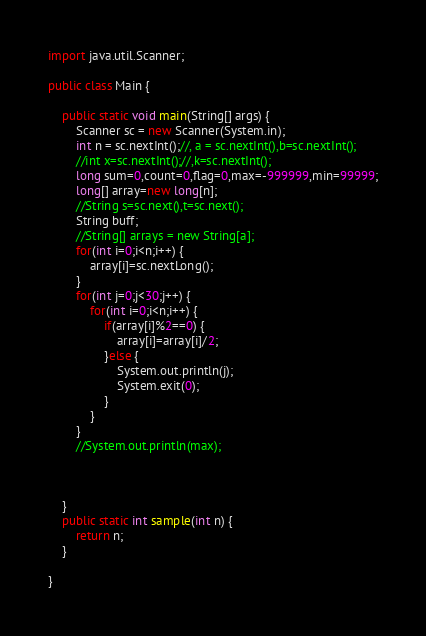Convert code to text. <code><loc_0><loc_0><loc_500><loc_500><_Java_>import java.util.Scanner;

public class Main {

	public static void main(String[] args) {
		Scanner sc = new Scanner(System.in);
		int n = sc.nextInt();//, a = sc.nextInt(),b=sc.nextInt();
		//int x=sc.nextInt();//,k=sc.nextInt();
		long sum=0,count=0,flag=0,max=-999999,min=99999;
		long[] array=new long[n];
		//String s=sc.next(),t=sc.next();
		String buff;
		//String[] arrays = new String[a];
		for(int i=0;i<n;i++) {
			array[i]=sc.nextLong();
		}
		for(int j=0;j<30;j++) {
			for(int i=0;i<n;i++) {
				if(array[i]%2==0) {
					array[i]=array[i]/2;
				}else {
					System.out.println(j);
					System.exit(0);
				}
			}
		}
		//System.out.println(max);



	}
	public static int sample(int n) {
		return n;
	}

}
</code> 